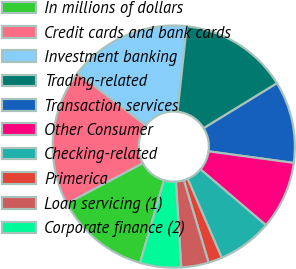<chart> <loc_0><loc_0><loc_500><loc_500><pie_chart><fcel>In millions of dollars<fcel>Credit cards and bank cards<fcel>Investment banking<fcel>Trading-related<fcel>Transaction services<fcel>Other Consumer<fcel>Checking-related<fcel>Primerica<fcel>Loan servicing (1)<fcel>Corporate finance (2)<nl><fcel>12.72%<fcel>18.16%<fcel>16.34%<fcel>14.53%<fcel>10.91%<fcel>9.09%<fcel>7.28%<fcel>1.84%<fcel>3.66%<fcel>5.47%<nl></chart> 